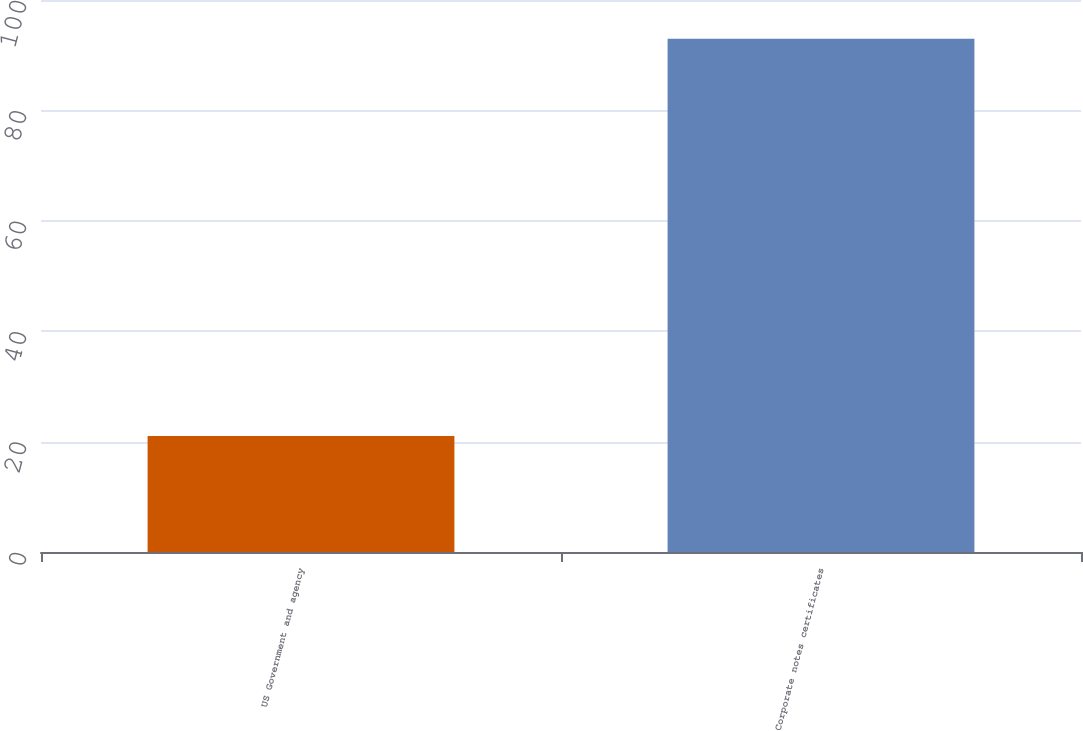<chart> <loc_0><loc_0><loc_500><loc_500><bar_chart><fcel>US Government and agency<fcel>Corporate notes certificates<nl><fcel>21<fcel>93<nl></chart> 